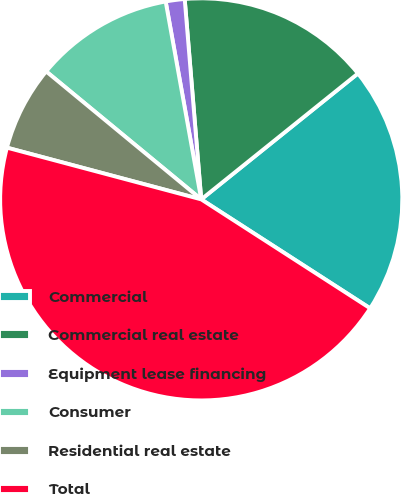<chart> <loc_0><loc_0><loc_500><loc_500><pie_chart><fcel>Commercial<fcel>Commercial real estate<fcel>Equipment lease financing<fcel>Consumer<fcel>Residential real estate<fcel>Total<nl><fcel>19.89%<fcel>15.54%<fcel>1.52%<fcel>11.19%<fcel>6.84%<fcel>45.03%<nl></chart> 